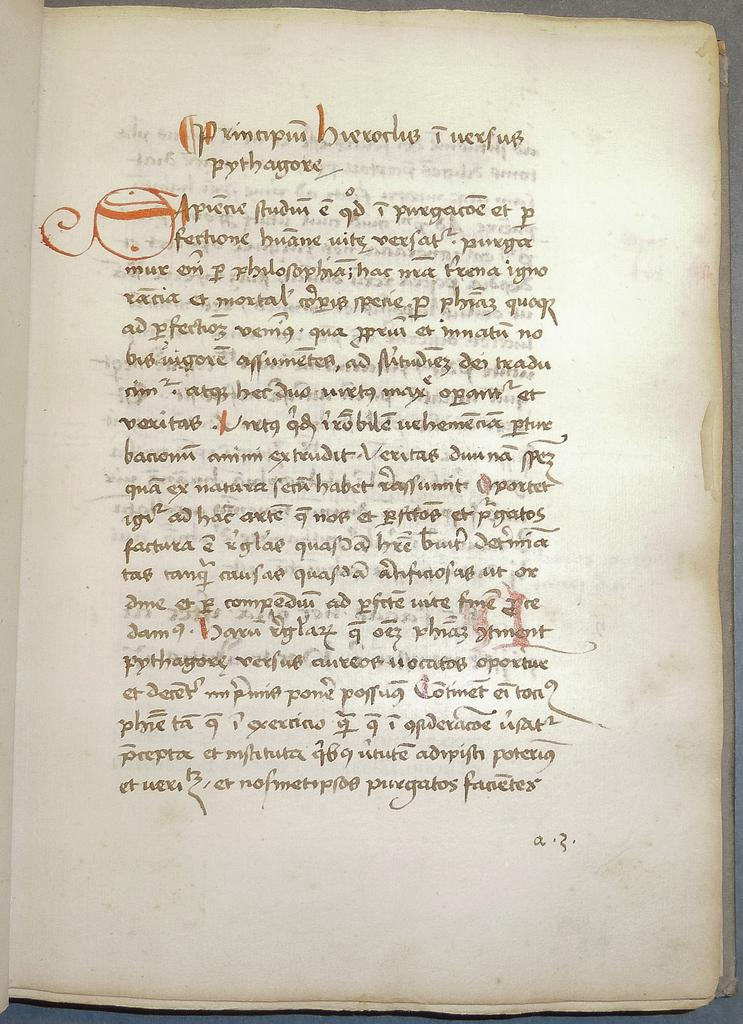<image>
Describe the image concisely. A white page of a book that seems ancient and with words in a foreign language. 